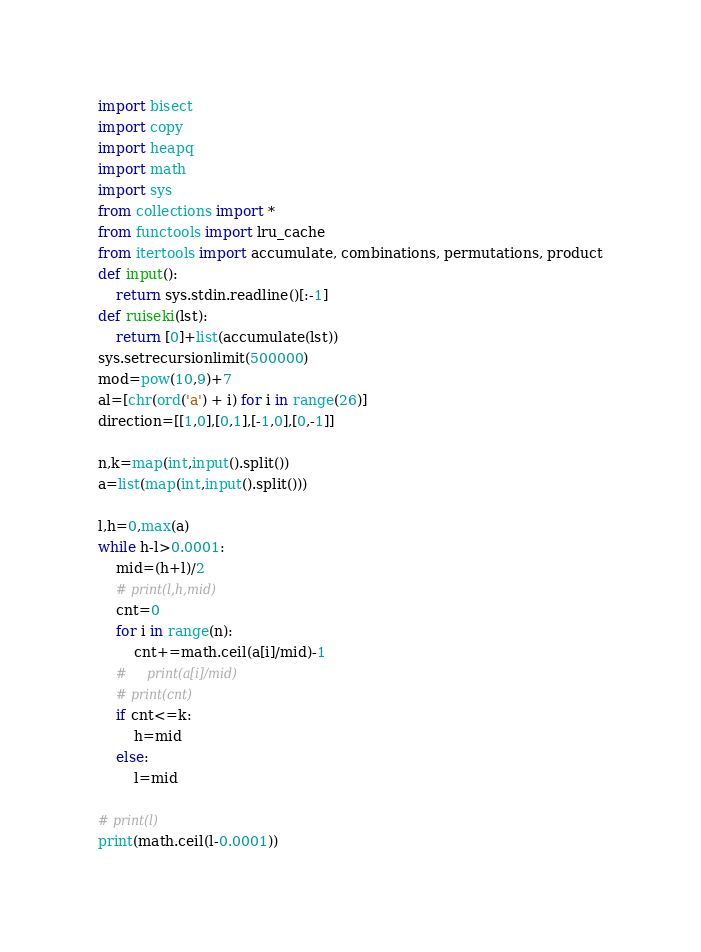<code> <loc_0><loc_0><loc_500><loc_500><_Python_>import bisect
import copy
import heapq
import math
import sys
from collections import *
from functools import lru_cache
from itertools import accumulate, combinations, permutations, product
def input():
    return sys.stdin.readline()[:-1]
def ruiseki(lst):
    return [0]+list(accumulate(lst))
sys.setrecursionlimit(500000)
mod=pow(10,9)+7
al=[chr(ord('a') + i) for i in range(26)]
direction=[[1,0],[0,1],[-1,0],[0,-1]]

n,k=map(int,input().split())
a=list(map(int,input().split()))

l,h=0,max(a)
while h-l>0.0001:
    mid=(h+l)/2
    # print(l,h,mid)
    cnt=0
    for i in range(n):
        cnt+=math.ceil(a[i]/mid)-1
    #     print(a[i]/mid)
    # print(cnt)
    if cnt<=k:
        h=mid
    else:
        l=mid

# print(l)
print(math.ceil(l-0.0001))</code> 